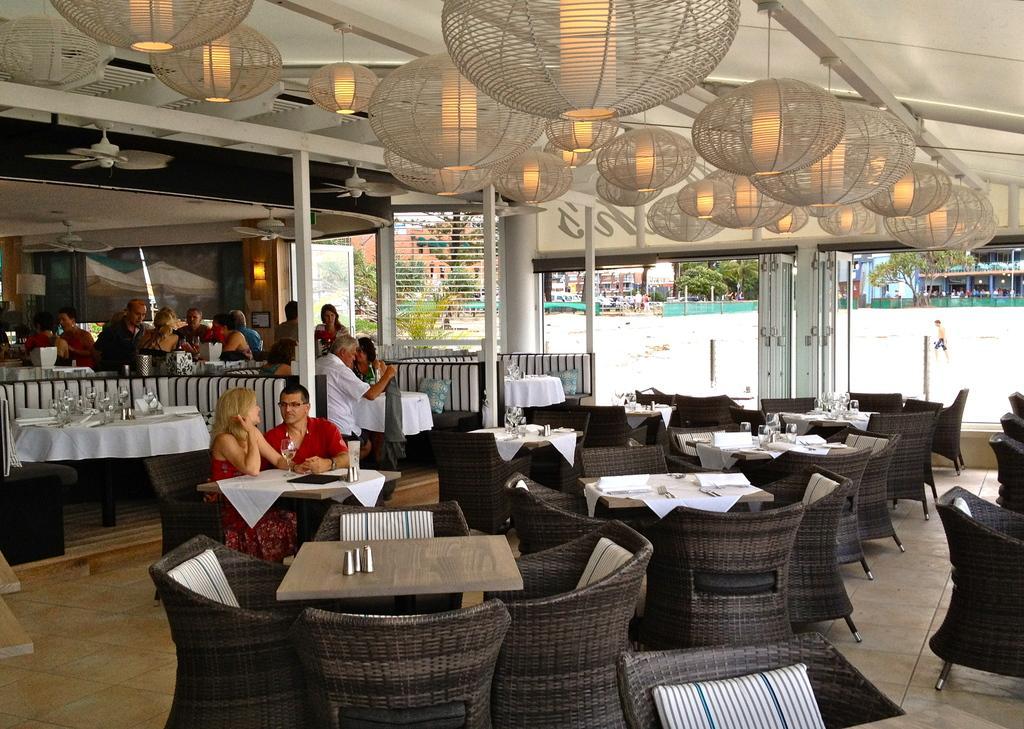Can you describe this image briefly? This is a lounge where we can see the tables and the chairs and on the table we can see some glasses and some jars and also we can see some beautiful lamps to the roof and also group of people sitting on the chairs. 